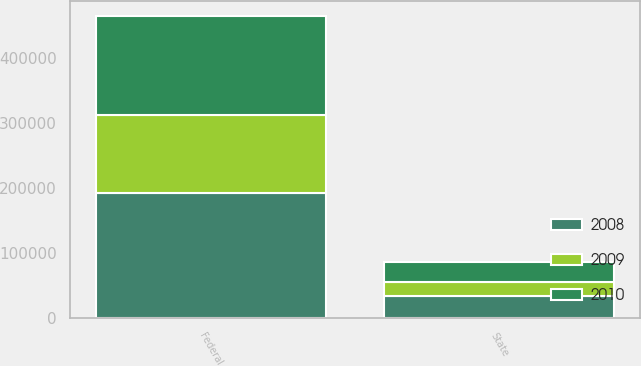Convert chart to OTSL. <chart><loc_0><loc_0><loc_500><loc_500><stacked_bar_chart><ecel><fcel>Federal<fcel>State<nl><fcel>2010<fcel>153502<fcel>31338<nl><fcel>2008<fcel>193181<fcel>34415<nl><fcel>2009<fcel>118764<fcel>20595<nl></chart> 